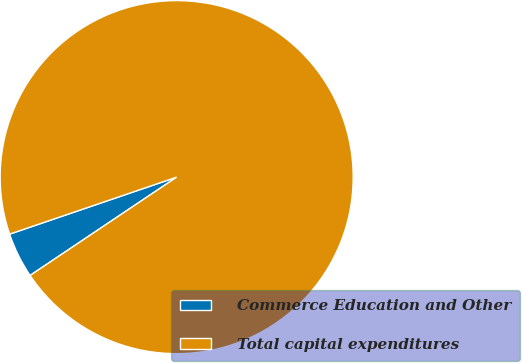Convert chart to OTSL. <chart><loc_0><loc_0><loc_500><loc_500><pie_chart><fcel>Commerce Education and Other<fcel>Total capital expenditures<nl><fcel>4.17%<fcel>95.83%<nl></chart> 